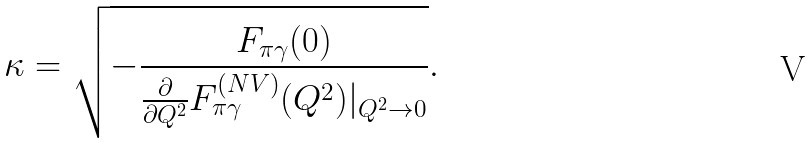<formula> <loc_0><loc_0><loc_500><loc_500>\kappa = \sqrt { - \frac { F _ { \pi \gamma } ( 0 ) } { \frac { \partial } { \partial Q ^ { 2 } } F ^ { ( N V ) } _ { \pi \gamma } ( Q ^ { 2 } ) | _ { Q ^ { 2 } \to 0 } } } .</formula> 